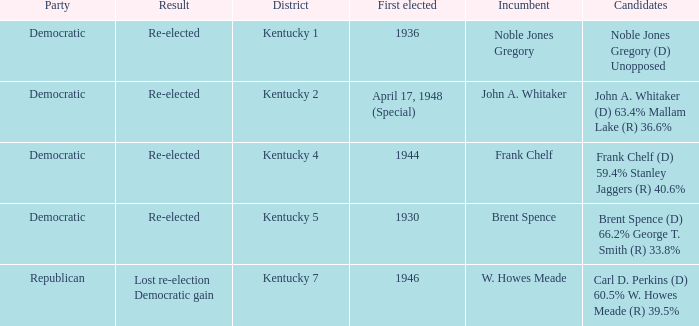How many times was incumbent Noble Jones Gregory first elected? 1.0. 